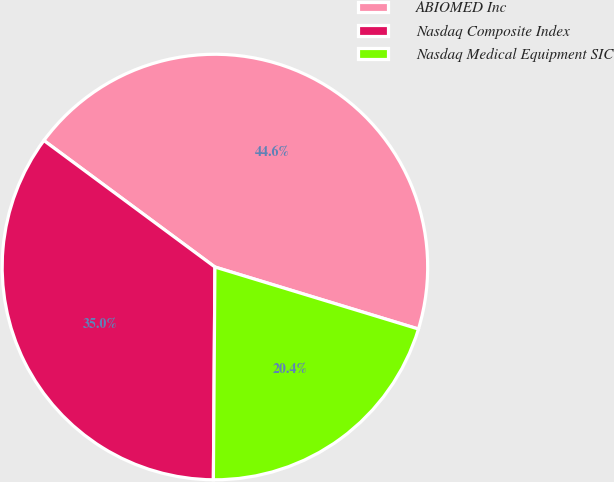Convert chart. <chart><loc_0><loc_0><loc_500><loc_500><pie_chart><fcel>ABIOMED Inc<fcel>Nasdaq Composite Index<fcel>Nasdaq Medical Equipment SIC<nl><fcel>44.57%<fcel>35.02%<fcel>20.41%<nl></chart> 